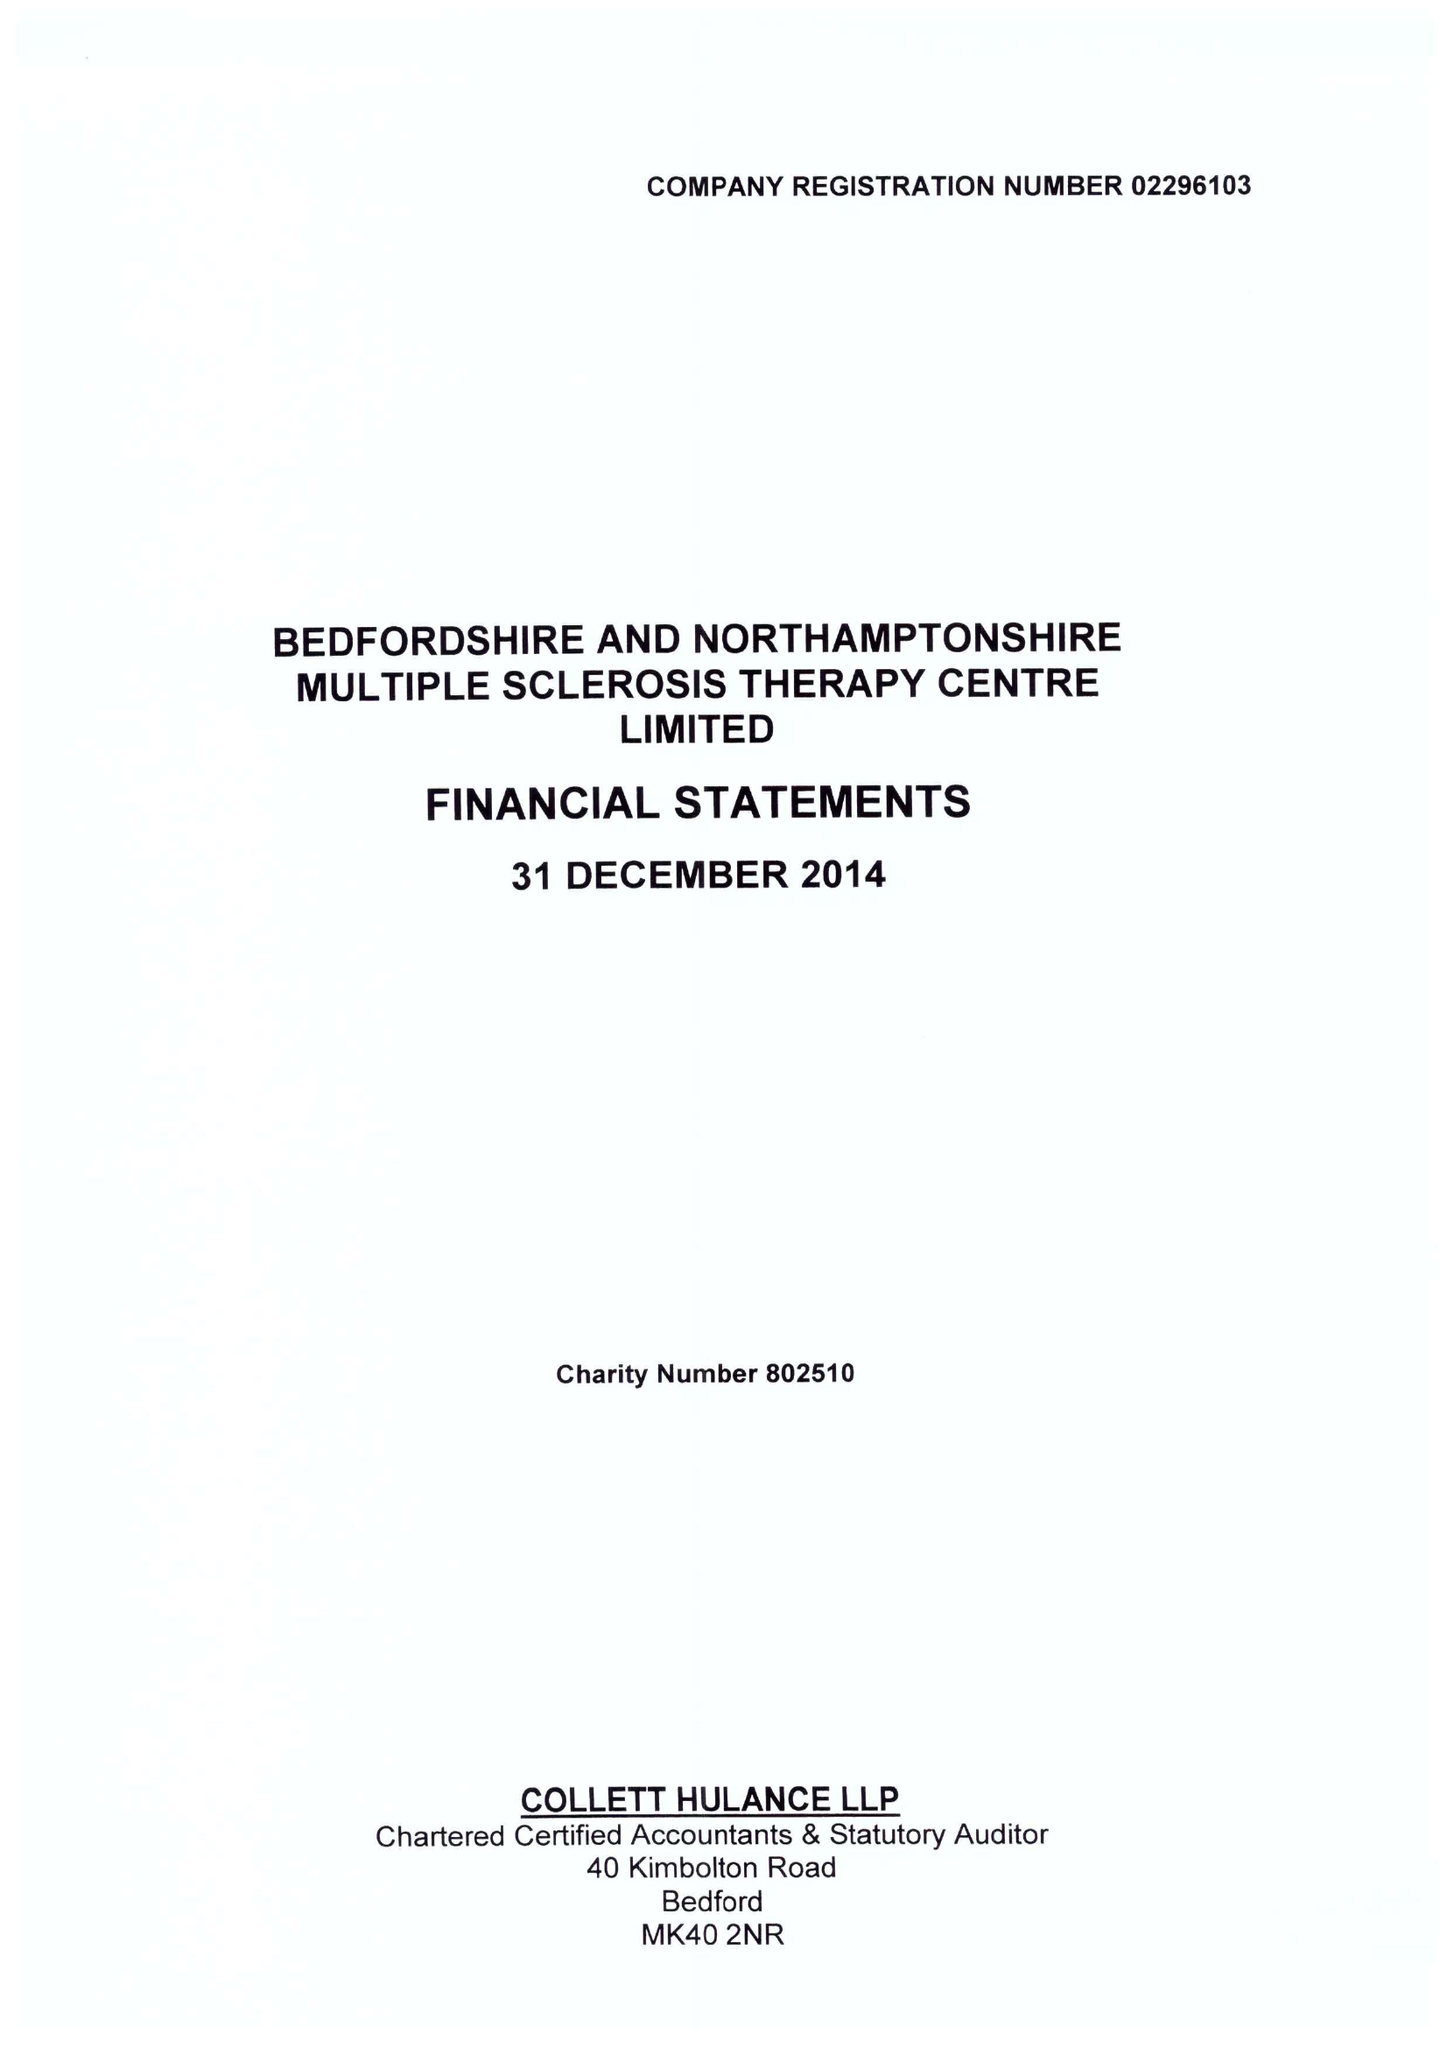What is the value for the address__street_line?
Answer the question using a single word or phrase. BARKERS LANE 